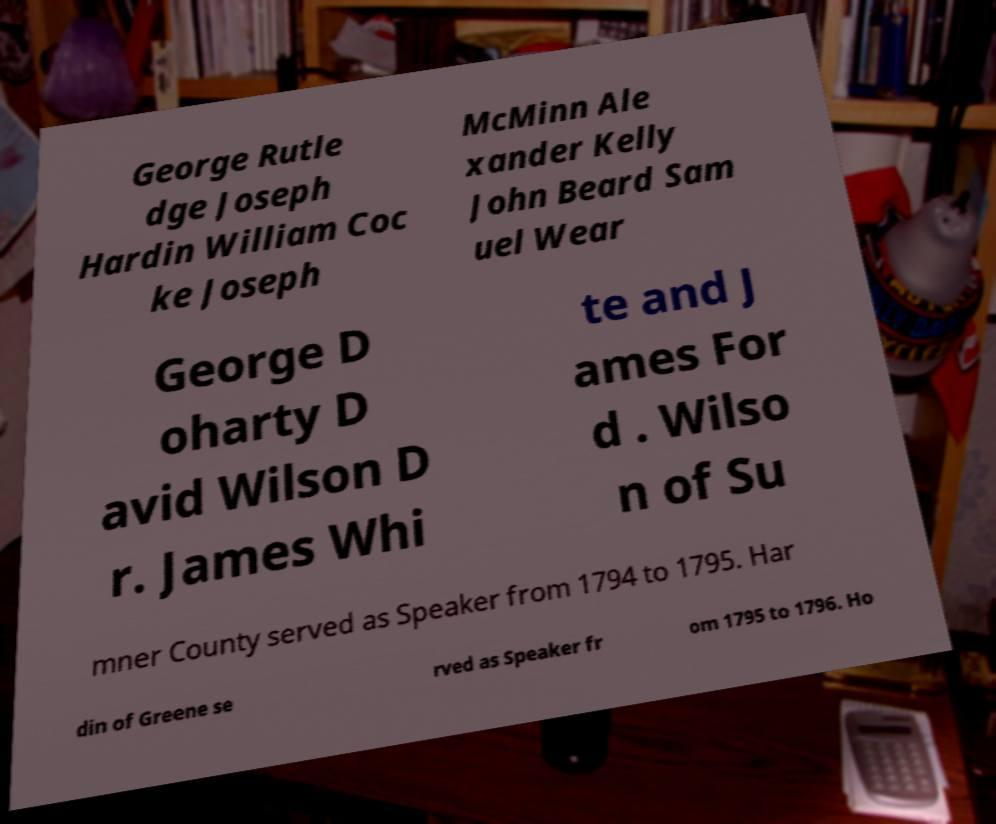For documentation purposes, I need the text within this image transcribed. Could you provide that? George Rutle dge Joseph Hardin William Coc ke Joseph McMinn Ale xander Kelly John Beard Sam uel Wear George D oharty D avid Wilson D r. James Whi te and J ames For d . Wilso n of Su mner County served as Speaker from 1794 to 1795. Har din of Greene se rved as Speaker fr om 1795 to 1796. Ho 